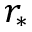Convert formula to latex. <formula><loc_0><loc_0><loc_500><loc_500>r _ { \ast }</formula> 